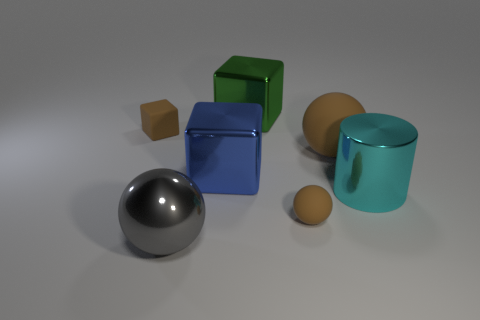What textures can be observed on the different objects in the image? The objects in the image showcase a variety of textures. The sphere has a smooth, glossy finish indicative of polished metal. The cube to the left seems to have a matte, slightly rough texture, like painted wood. The cyan object has a shiny, reflective surface suggesting a metallic coating, while the cylinder has a translucency characteristic of tinted glass or clear plastic with a smooth finish. 